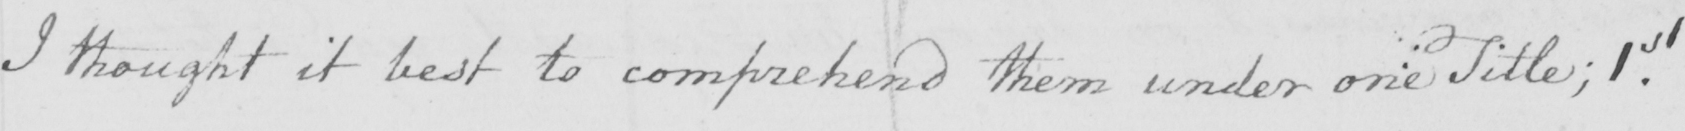Transcribe the text shown in this historical manuscript line. I thought it best to comprehend them under one title ; 1st 